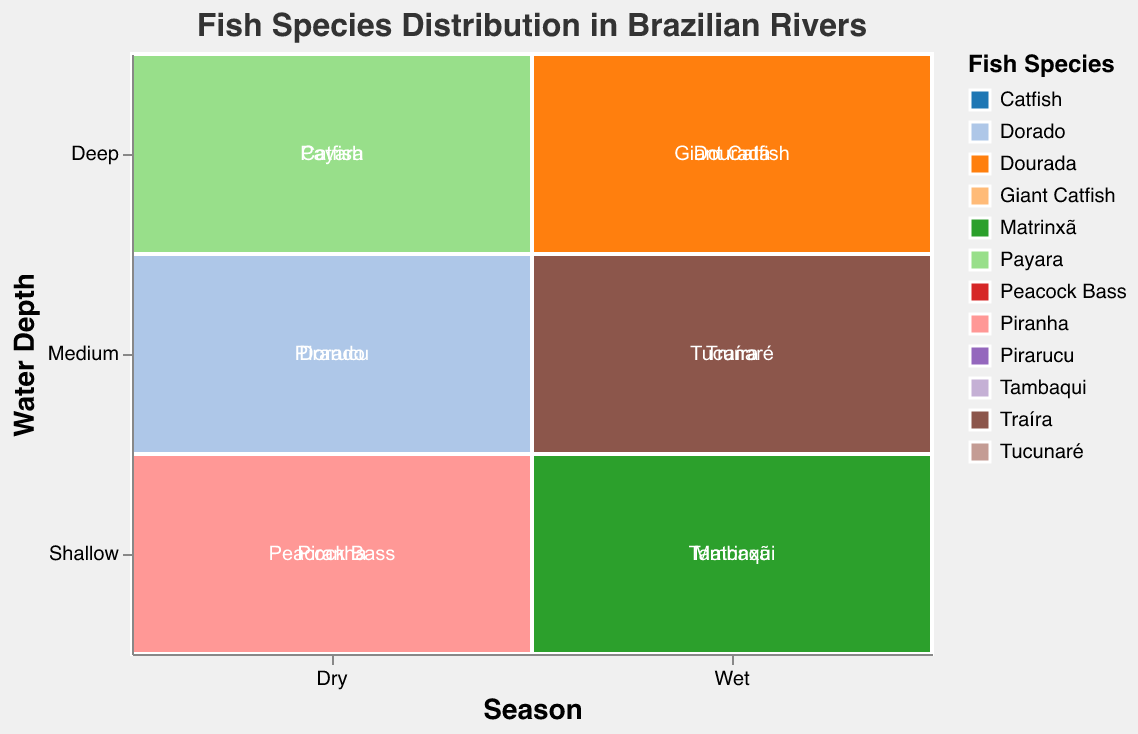What is the title of the plot? The title of the plot is always displayed prominently at the top of a figure and serves as the main descriptor of the visualized data.
Answer: Fish Species Distribution in Brazilian Rivers Which fish species is found in shallow water during the dry season? Look for the "Dry" season along the x-axis and "Shallow" water along the y-axis. The fish species within this region will be shown.
Answer: Peacock Bass, Piranha How many fish species are found in deep water during the wet season? Identify the "Wet" section on the x-axis and "Deep" section on the y-axis. Count the distinct fish species within this cell.
Answer: 2 Which season has more fish species diversity in shallow waters? Compare the sections under "Shallow" for both "Dry" and "Wet" seasons and count the number of distinct fish species in each.
Answer: Wet What is the total count of Peacock Bass in the dry season and Tucunaré in the wet season? Locate the counts for Peacock Bass in dry season and Tucunaré in wet season, then sum the two values (45 + 50).
Answer: 95 Which fish species has the highest count in medium water depth during the wet season? Look at the "Wet" section for "Medium" water depth and compare the counts for each fish species.
Answer: Tucunaré Are there more Catfish in dry season or Giant Catfish in wet season? Locate the count for Catfish in the dry season and Giant Catfish in the wet season, then compare the two values (25 and 30).
Answer: Giant Catfish How many more Piranhas are there in the dry season compared to Payara in the same season? Find the counts for both Piranha and Payara in the dry season, and compute the difference (30 - 10).
Answer: 20 Which water depth category has the highest total fish count in the wet season? Sum the counts for each water depth category (Shallow, Medium, Deep) in the wet season and compare the totals (Shallow: 75, Medium: 75, Deep: 50).
Answer: Shallow and Medium Is there any fish species that appears in both dry and wet seasons? Compare the list of fish species in each season and identify any overlapping species (none in this case).
Answer: No 